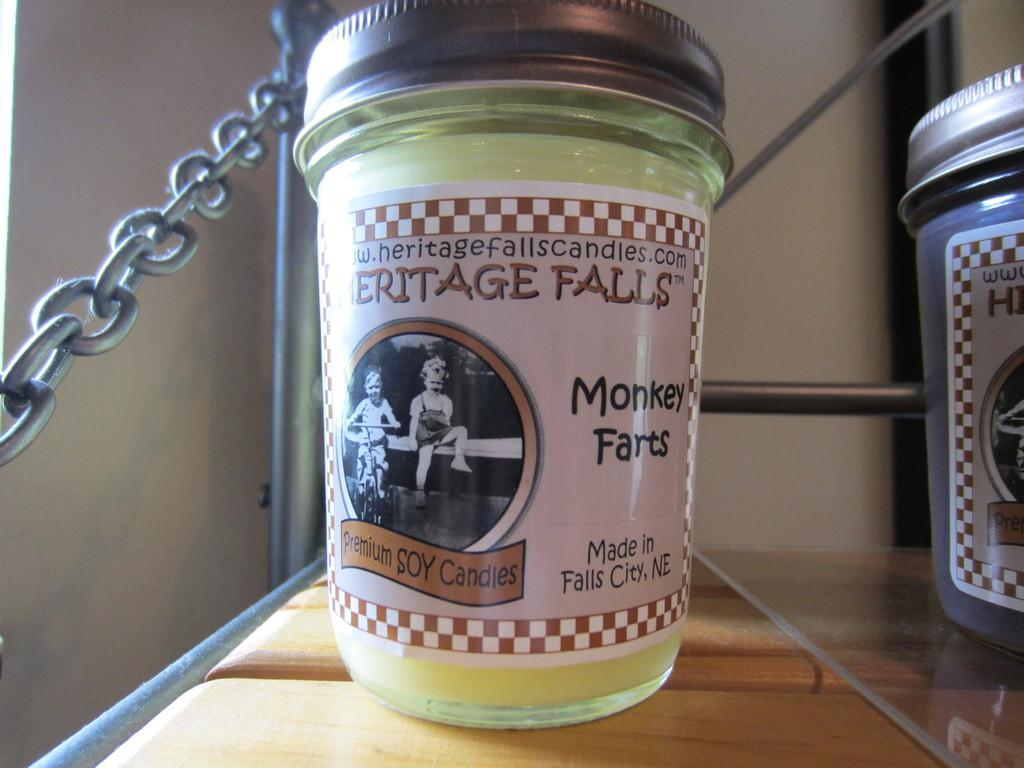<image>
Provide a brief description of the given image. A premium soy candle from Heritage Falls is displayed on a wooden shelf. 